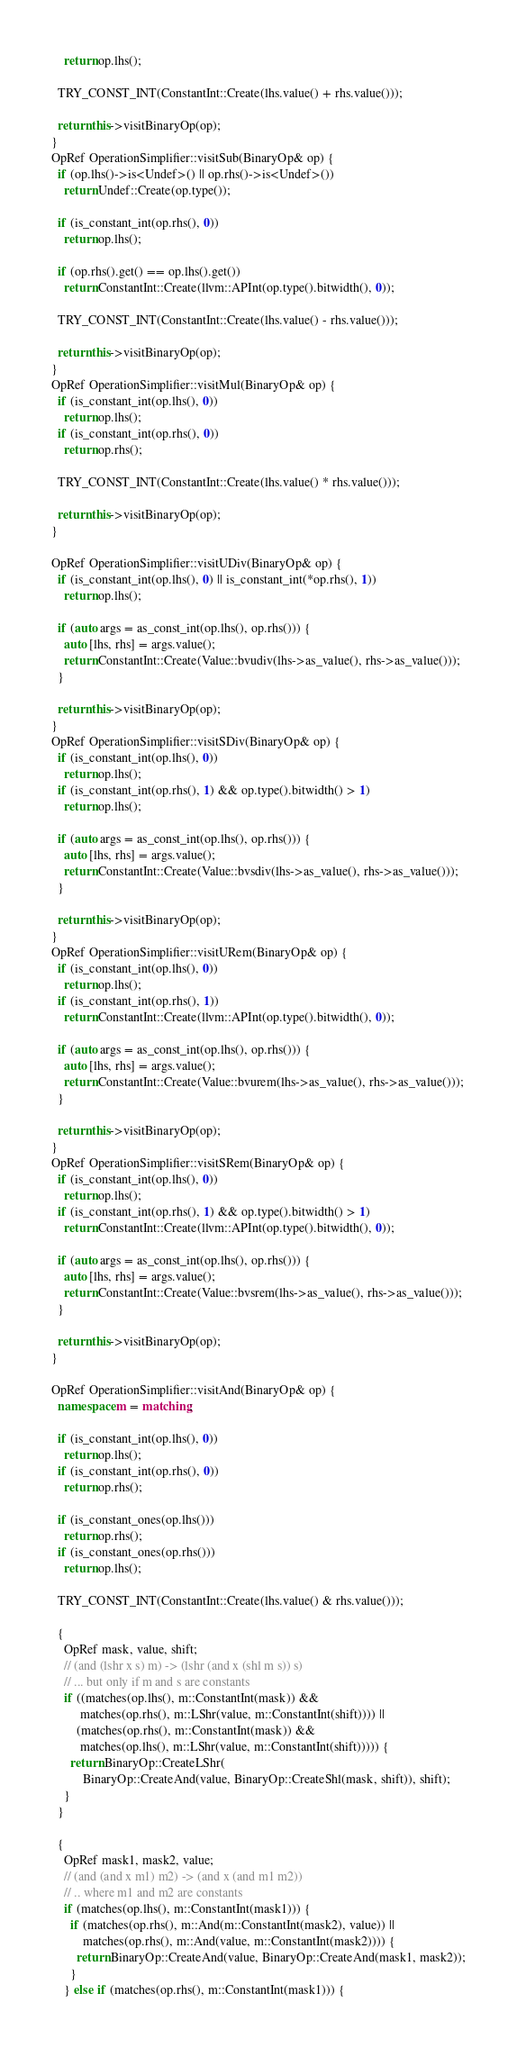Convert code to text. <code><loc_0><loc_0><loc_500><loc_500><_C++_>    return op.lhs();

  TRY_CONST_INT(ConstantInt::Create(lhs.value() + rhs.value()));

  return this->visitBinaryOp(op);
}
OpRef OperationSimplifier::visitSub(BinaryOp& op) {
  if (op.lhs()->is<Undef>() || op.rhs()->is<Undef>())
    return Undef::Create(op.type());

  if (is_constant_int(op.rhs(), 0))
    return op.lhs();

  if (op.rhs().get() == op.lhs().get())
    return ConstantInt::Create(llvm::APInt(op.type().bitwidth(), 0));

  TRY_CONST_INT(ConstantInt::Create(lhs.value() - rhs.value()));

  return this->visitBinaryOp(op);
}
OpRef OperationSimplifier::visitMul(BinaryOp& op) {
  if (is_constant_int(op.lhs(), 0))
    return op.lhs();
  if (is_constant_int(op.rhs(), 0))
    return op.rhs();

  TRY_CONST_INT(ConstantInt::Create(lhs.value() * rhs.value()));

  return this->visitBinaryOp(op);
}

OpRef OperationSimplifier::visitUDiv(BinaryOp& op) {
  if (is_constant_int(op.lhs(), 0) || is_constant_int(*op.rhs(), 1))
    return op.lhs();

  if (auto args = as_const_int(op.lhs(), op.rhs())) {
    auto [lhs, rhs] = args.value();
    return ConstantInt::Create(Value::bvudiv(lhs->as_value(), rhs->as_value()));
  }

  return this->visitBinaryOp(op);
}
OpRef OperationSimplifier::visitSDiv(BinaryOp& op) {
  if (is_constant_int(op.lhs(), 0))
    return op.lhs();
  if (is_constant_int(op.rhs(), 1) && op.type().bitwidth() > 1)
    return op.lhs();

  if (auto args = as_const_int(op.lhs(), op.rhs())) {
    auto [lhs, rhs] = args.value();
    return ConstantInt::Create(Value::bvsdiv(lhs->as_value(), rhs->as_value()));
  }

  return this->visitBinaryOp(op);
}
OpRef OperationSimplifier::visitURem(BinaryOp& op) {
  if (is_constant_int(op.lhs(), 0))
    return op.lhs();
  if (is_constant_int(op.rhs(), 1))
    return ConstantInt::Create(llvm::APInt(op.type().bitwidth(), 0));

  if (auto args = as_const_int(op.lhs(), op.rhs())) {
    auto [lhs, rhs] = args.value();
    return ConstantInt::Create(Value::bvurem(lhs->as_value(), rhs->as_value()));
  }

  return this->visitBinaryOp(op);
}
OpRef OperationSimplifier::visitSRem(BinaryOp& op) {
  if (is_constant_int(op.lhs(), 0))
    return op.lhs();
  if (is_constant_int(op.rhs(), 1) && op.type().bitwidth() > 1)
    return ConstantInt::Create(llvm::APInt(op.type().bitwidth(), 0));

  if (auto args = as_const_int(op.lhs(), op.rhs())) {
    auto [lhs, rhs] = args.value();
    return ConstantInt::Create(Value::bvsrem(lhs->as_value(), rhs->as_value()));
  }

  return this->visitBinaryOp(op);
}

OpRef OperationSimplifier::visitAnd(BinaryOp& op) {
  namespace m = matching;

  if (is_constant_int(op.lhs(), 0))
    return op.lhs();
  if (is_constant_int(op.rhs(), 0))
    return op.rhs();

  if (is_constant_ones(op.lhs()))
    return op.rhs();
  if (is_constant_ones(op.rhs()))
    return op.lhs();

  TRY_CONST_INT(ConstantInt::Create(lhs.value() & rhs.value()));

  {
    OpRef mask, value, shift;
    // (and (lshr x s) m) -> (lshr (and x (shl m s)) s)
    // ... but only if m and s are constants
    if ((matches(op.lhs(), m::ConstantInt(mask)) &&
         matches(op.rhs(), m::LShr(value, m::ConstantInt(shift)))) ||
        (matches(op.rhs(), m::ConstantInt(mask)) &&
         matches(op.lhs(), m::LShr(value, m::ConstantInt(shift))))) {
      return BinaryOp::CreateLShr(
          BinaryOp::CreateAnd(value, BinaryOp::CreateShl(mask, shift)), shift);
    }
  }

  {
    OpRef mask1, mask2, value;
    // (and (and x m1) m2) -> (and x (and m1 m2))
    // .. where m1 and m2 are constants
    if (matches(op.lhs(), m::ConstantInt(mask1))) {
      if (matches(op.rhs(), m::And(m::ConstantInt(mask2), value)) ||
          matches(op.rhs(), m::And(value, m::ConstantInt(mask2)))) {
        return BinaryOp::CreateAnd(value, BinaryOp::CreateAnd(mask1, mask2));
      }
    } else if (matches(op.rhs(), m::ConstantInt(mask1))) {</code> 